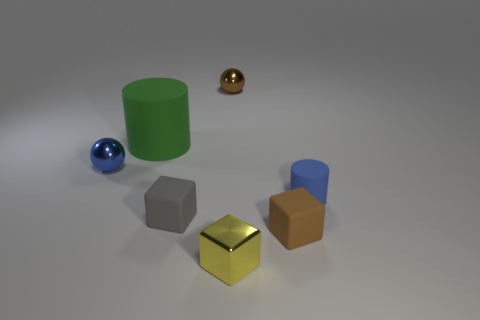Add 3 balls. How many objects exist? 10 Subtract all cubes. How many objects are left? 4 Add 5 tiny blue matte objects. How many tiny blue matte objects are left? 6 Add 2 tiny blue metallic balls. How many tiny blue metallic balls exist? 3 Subtract 0 gray cylinders. How many objects are left? 7 Subtract all brown shiny spheres. Subtract all large things. How many objects are left? 5 